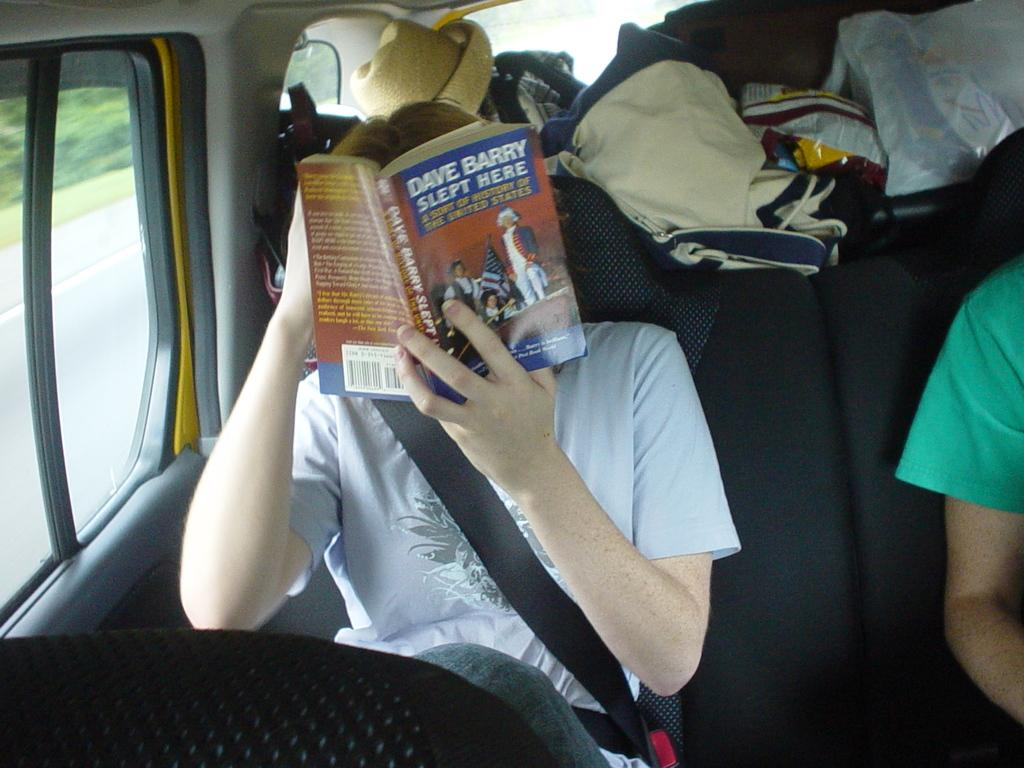<image>
Share a concise interpretation of the image provided. A man sits in a vehicle reading a book called Dave Barry Slept here. 